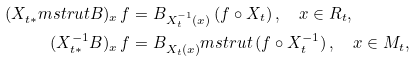Convert formula to latex. <formula><loc_0><loc_0><loc_500><loc_500>( X _ { t \ast } ^ { \ } m s t r u t B ) _ { x } \, f & = B _ { X _ { t } ^ { - 1 } ( x ) } \, ( f \circ X _ { t } ) \, , \quad x \in R _ { t } , \\ ( X _ { t \ast } ^ { - 1 } B ) _ { x } \, f & = B _ { X _ { t } ( x ) } ^ { \ } m s t r u t \, ( f \circ X _ { t } ^ { - 1 } ) \, , \quad x \in M _ { t } ,</formula> 